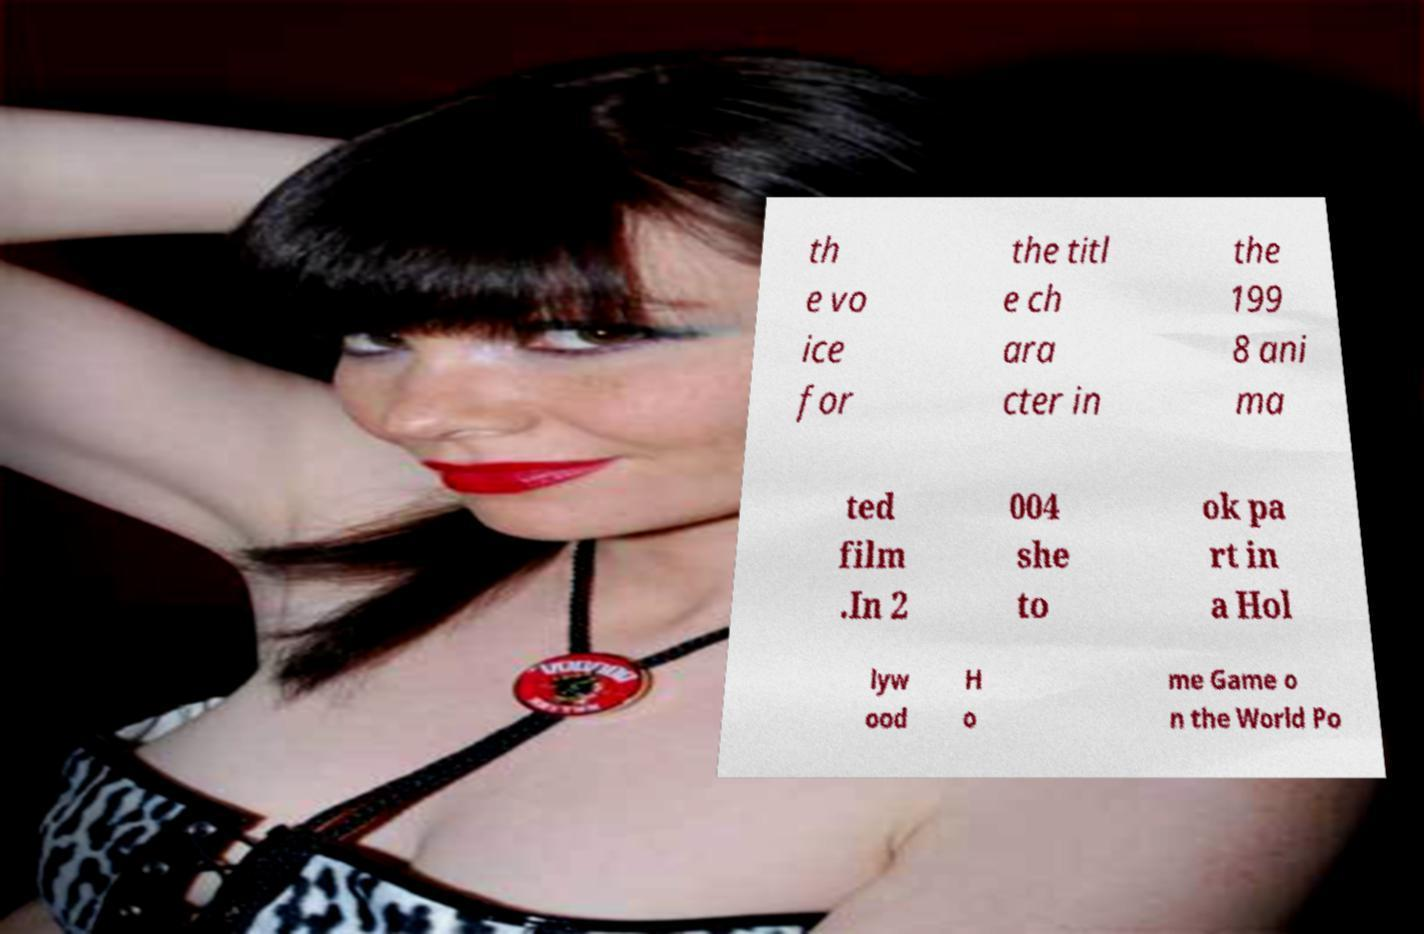Can you accurately transcribe the text from the provided image for me? th e vo ice for the titl e ch ara cter in the 199 8 ani ma ted film .In 2 004 she to ok pa rt in a Hol lyw ood H o me Game o n the World Po 